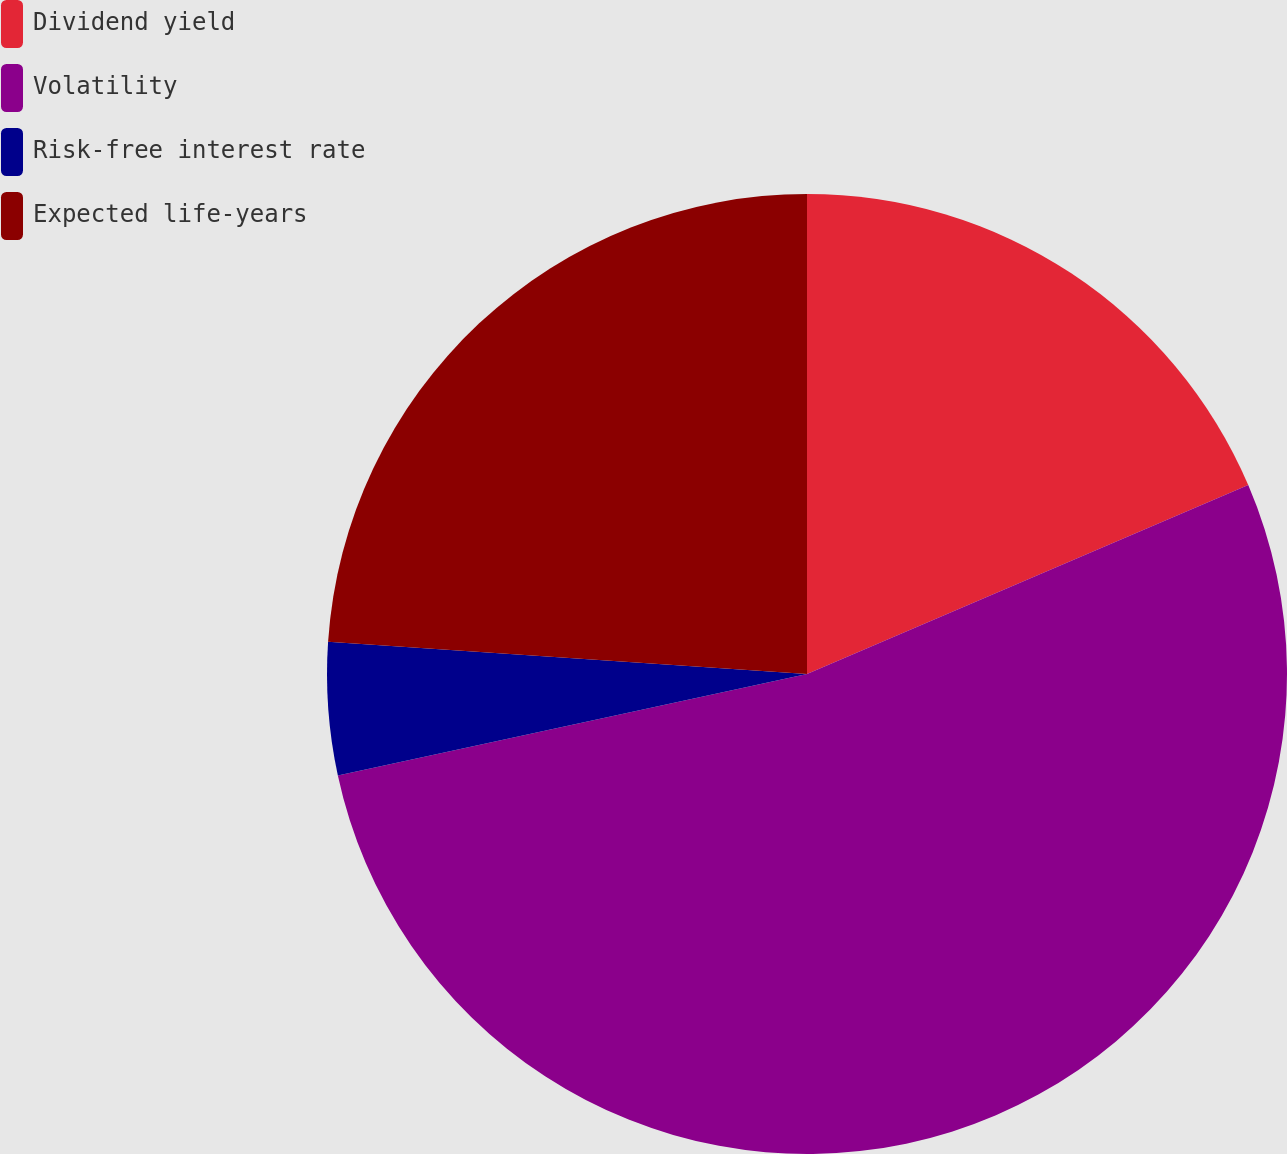<chart> <loc_0><loc_0><loc_500><loc_500><pie_chart><fcel>Dividend yield<fcel>Volatility<fcel>Risk-free interest rate<fcel>Expected life-years<nl><fcel>18.56%<fcel>53.05%<fcel>4.46%<fcel>23.93%<nl></chart> 